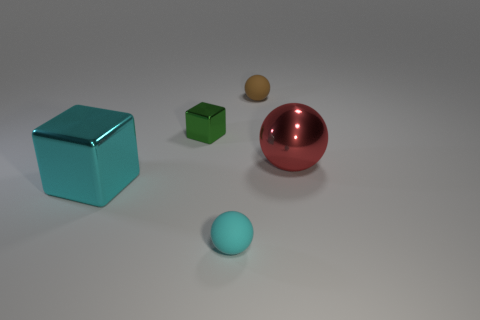Are there any brown matte spheres of the same size as the cyan cube?
Offer a terse response. No. There is a green thing that is the same size as the brown matte sphere; what material is it?
Keep it short and to the point. Metal. There is a red object in front of the rubber sphere behind the cyan rubber thing; what is its size?
Keep it short and to the point. Large. There is a red metallic thing behind the cyan cube; is its size the same as the big cyan block?
Offer a very short reply. Yes. Is the number of small rubber spheres that are behind the big cyan cube greater than the number of cyan spheres that are on the right side of the red ball?
Give a very brief answer. Yes. What is the shape of the thing that is both in front of the big metallic sphere and behind the small cyan ball?
Keep it short and to the point. Cube. There is a metallic thing that is to the right of the brown matte sphere; what shape is it?
Provide a succinct answer. Sphere. What size is the metallic thing that is to the right of the rubber sphere that is behind the small object that is in front of the green thing?
Provide a short and direct response. Large. Is the tiny cyan object the same shape as the tiny brown object?
Offer a terse response. Yes. What size is the sphere that is both left of the big red shiny sphere and behind the cyan shiny block?
Ensure brevity in your answer.  Small. 